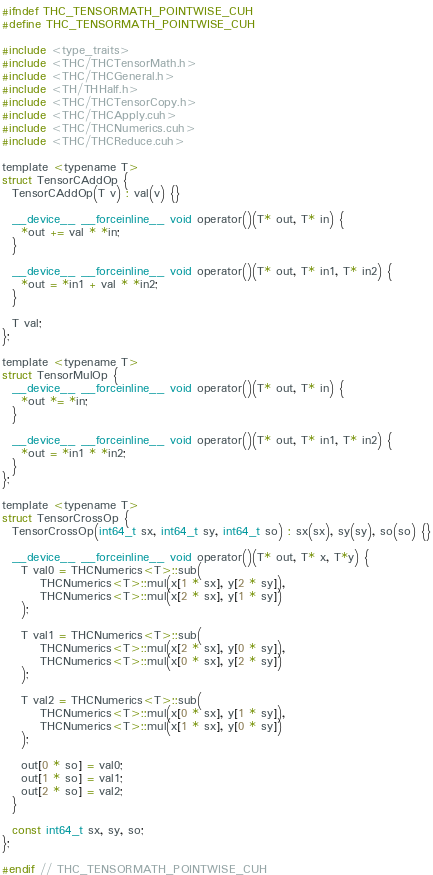<code> <loc_0><loc_0><loc_500><loc_500><_Cuda_>#ifndef THC_TENSORMATH_POINTWISE_CUH
#define THC_TENSORMATH_POINTWISE_CUH

#include <type_traits>
#include <THC/THCTensorMath.h>
#include <THC/THCGeneral.h>
#include <TH/THHalf.h>
#include <THC/THCTensorCopy.h>
#include <THC/THCApply.cuh>
#include <THC/THCNumerics.cuh>
#include <THC/THCReduce.cuh>

template <typename T>
struct TensorCAddOp {
  TensorCAddOp(T v) : val(v) {}

  __device__ __forceinline__ void operator()(T* out, T* in) {
    *out += val * *in;
  }

  __device__ __forceinline__ void operator()(T* out, T* in1, T* in2) {
    *out = *in1 + val * *in2;
  }

  T val;
};

template <typename T>
struct TensorMulOp {
  __device__ __forceinline__ void operator()(T* out, T* in) {
    *out *= *in;
  }

  __device__ __forceinline__ void operator()(T* out, T* in1, T* in2) {
    *out = *in1 * *in2;
  }
};

template <typename T>
struct TensorCrossOp {
  TensorCrossOp(int64_t sx, int64_t sy, int64_t so) : sx(sx), sy(sy), so(so) {}

  __device__ __forceinline__ void operator()(T* out, T* x, T*y) {
    T val0 = THCNumerics<T>::sub(
        THCNumerics<T>::mul(x[1 * sx], y[2 * sy]),
        THCNumerics<T>::mul(x[2 * sx], y[1 * sy])
    );

    T val1 = THCNumerics<T>::sub(
        THCNumerics<T>::mul(x[2 * sx], y[0 * sy]),
        THCNumerics<T>::mul(x[0 * sx], y[2 * sy])
    );

    T val2 = THCNumerics<T>::sub(
        THCNumerics<T>::mul(x[0 * sx], y[1 * sy]),
        THCNumerics<T>::mul(x[1 * sx], y[0 * sy])
    );

    out[0 * so] = val0;
    out[1 * so] = val1;
    out[2 * so] = val2;
  }

  const int64_t sx, sy, so;
};

#endif // THC_TENSORMATH_POINTWISE_CUH
</code> 